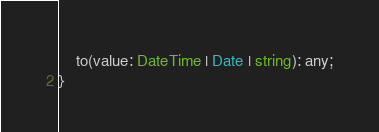<code> <loc_0><loc_0><loc_500><loc_500><_TypeScript_>    to(value: DateTime | Date | string): any;
}
</code> 